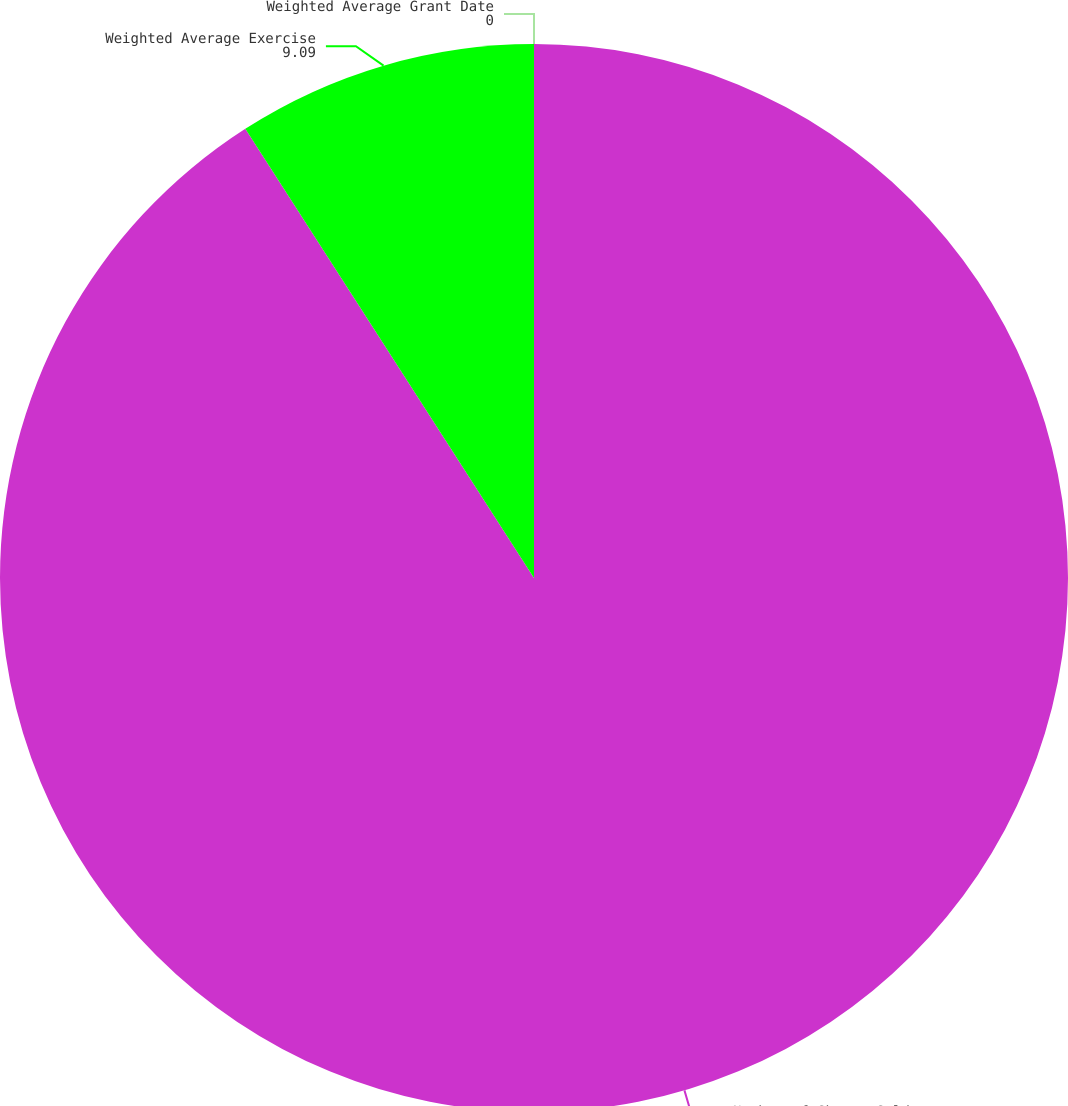Convert chart. <chart><loc_0><loc_0><loc_500><loc_500><pie_chart><fcel>Number of Shares Sold<fcel>Weighted Average Exercise<fcel>Weighted Average Grant Date<nl><fcel>90.9%<fcel>9.09%<fcel>0.0%<nl></chart> 